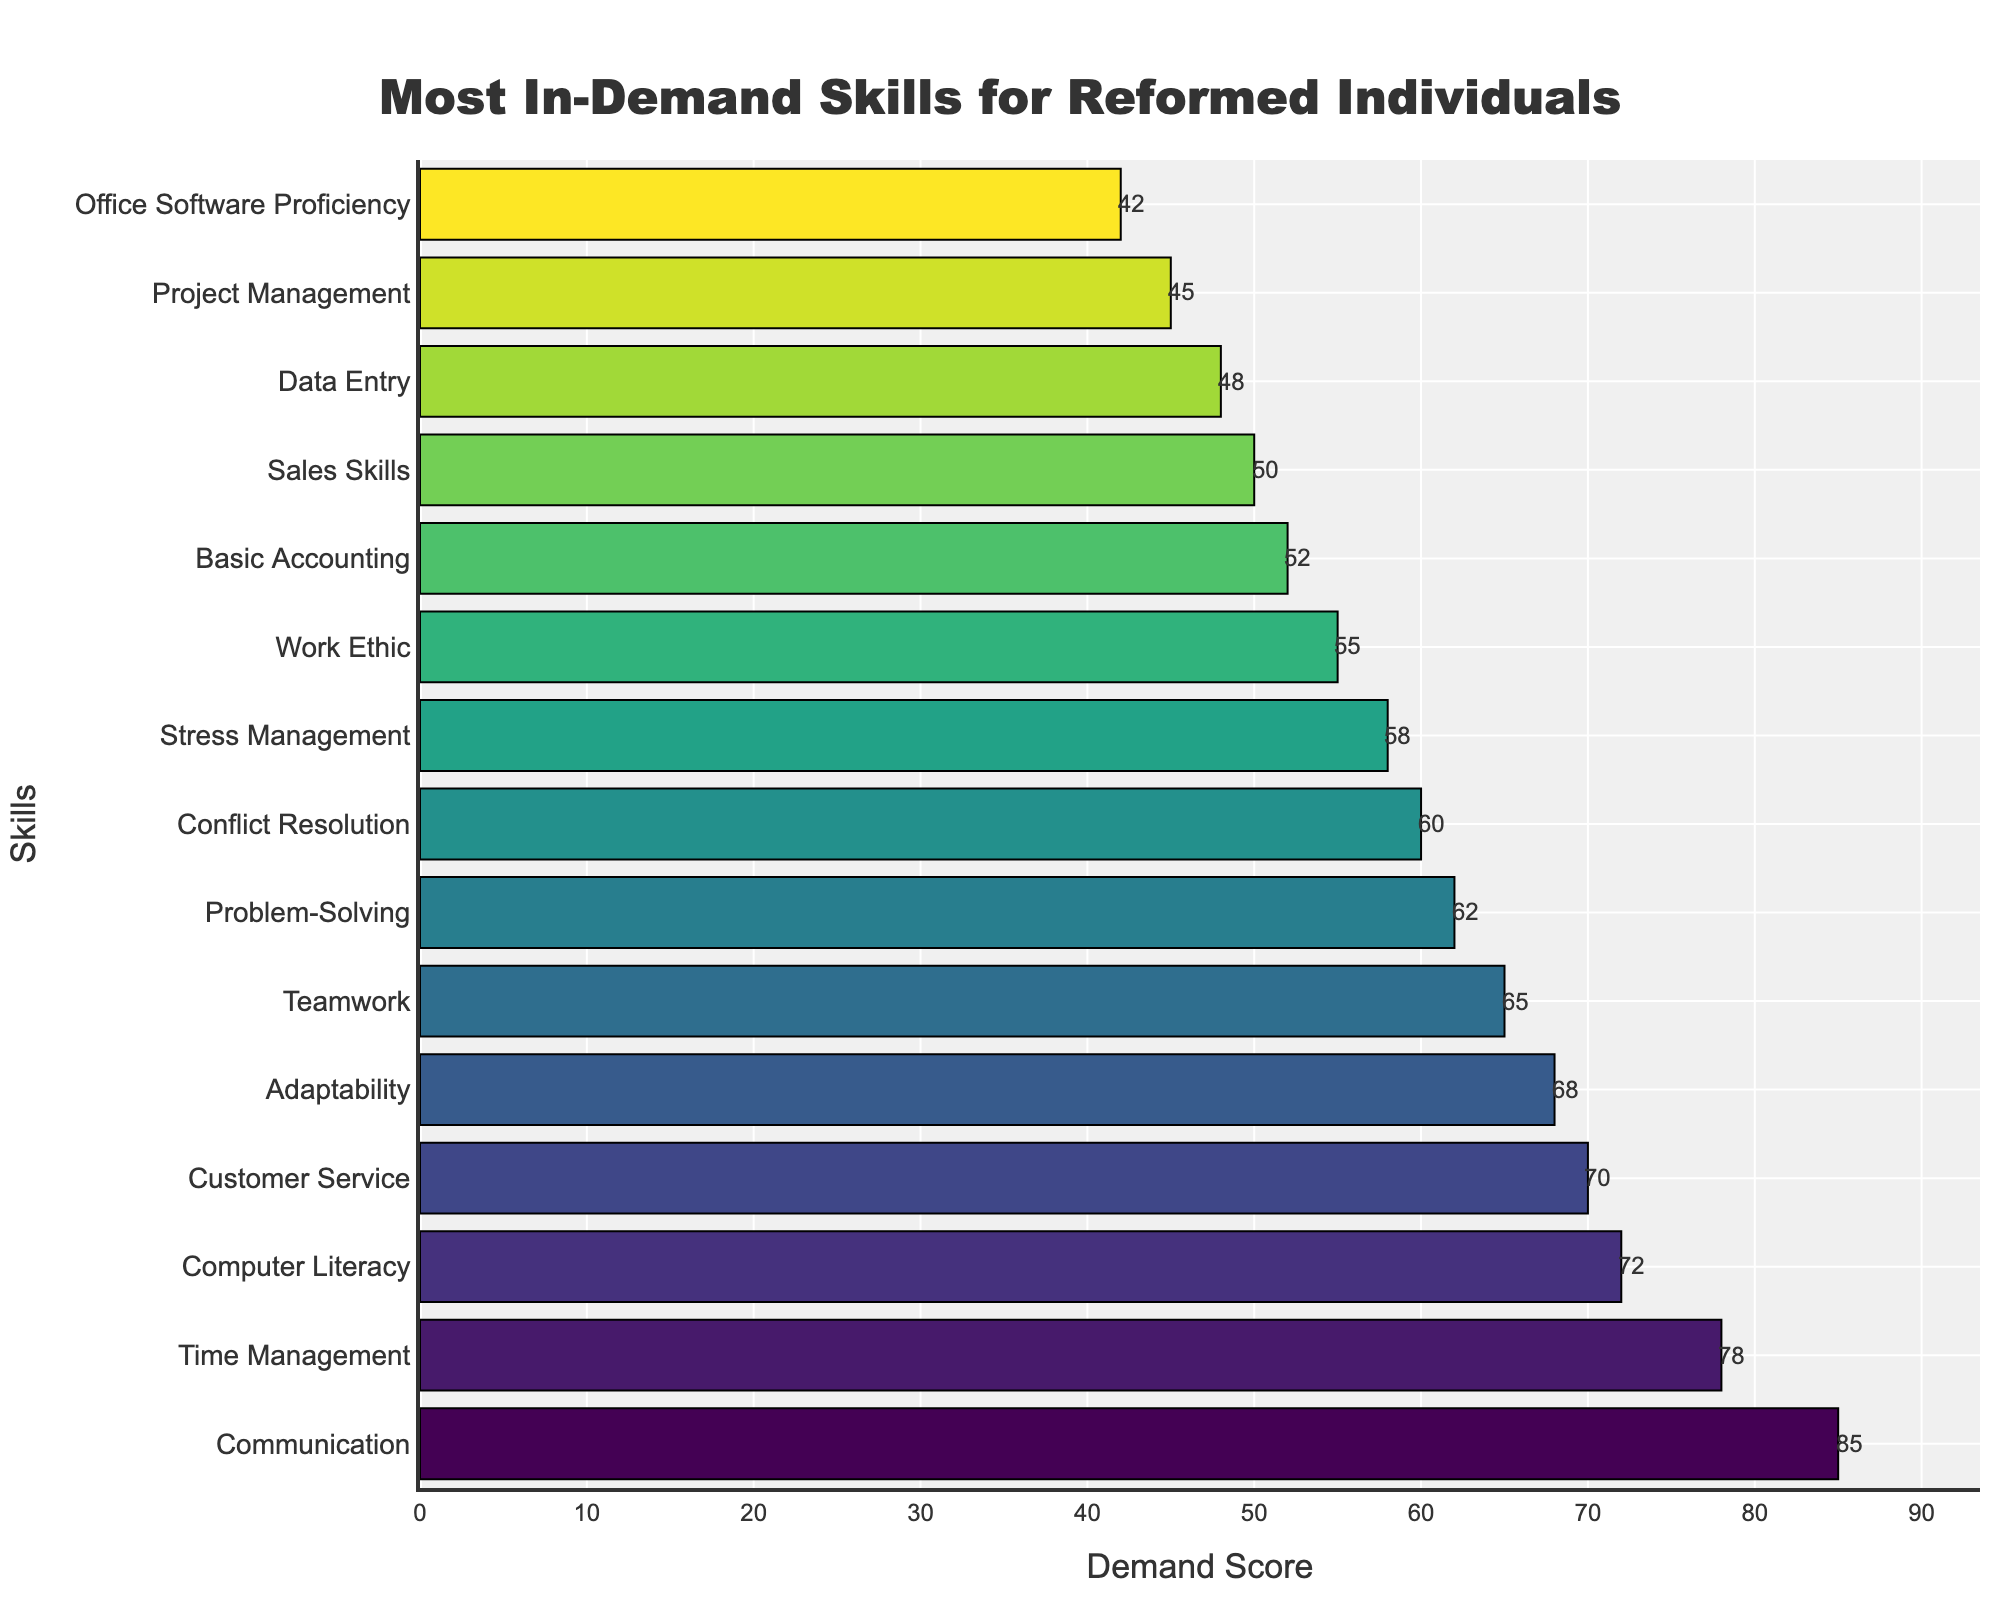What is the highest demand skill according to the figure? The longest bar at the top of the figure represents the highest demand skill. According to the bar chart, the top skill is Communication with a Demand Score of 85.
Answer: Communication Which skill has a higher demand score, Adaptability or Teamwork? Identify the bars representing Adaptability and Teamwork. Adaptability has a Demand Score of 68, and Teamwork has a Demand Score of 65. Since 68 is greater than 65, Adaptability has a higher demand score.
Answer: Adaptability What is the sum of the demand scores for Computer Literacy and Sales Skills? Find the respective bars and their scores. Computer Literacy has a Demand Score of 72, and Sales Skills have a Demand Score of 50. Adding these together yields 72 + 50.
Answer: 122 Which skill has the third highest demand score? Order the bars from highest to lowest demand score. The third bar from the top represents the third highest demand score. According to the figure, the third highest demand skill is Computer Literacy with a Demand Score of 72.
Answer: Computer Literacy How many skills have a demand score greater than 60? Count the number of bars that extend beyond the 60 mark on the x-axis. According to the chart, there are 7 skills (Communication, Time Management, Computer Literacy, Customer Service, Adaptability, Teamwork, Problem-Solving) that have a demand score greater than 60.
Answer: 7 Which skill has the lowest demand score, and what is that score? Look for the shortest bar at the bottom of the chart. The shortest bar represents Office Software Proficiency, which has a Demand Score of 42.
Answer: Office Software Proficiency, 42 What is the average demand score of the top 5 skills? List the Demand Scores of the top 5 skills: Communication (85), Time Management (78), Computer Literacy (72), Customer Service (70), and Adaptability (68). Calculate the average: (85 + 78 + 72 + 70 + 68) / 5 = 74.6.
Answer: 74.6 By how much does the demand score for Conflict Resolution exceed that of Work Ethic? Determine the Demand Scores for Conflict Resolution (60) and Work Ethic (55). Subtract the Demand Score of Work Ethic from that of Conflict Resolution: 60 - 55.
Answer: 5 Which skills have a demand score between 50 and 60? Identify the bars with scores falling in the range of 50 to 60. According to the chart, these skills are Conflict Resolution (60), Stress Management (58), Work Ethic (55), and Basic Accounting (52).
Answer: Conflict Resolution, Stress Management, Work Ethic, Basic Accounting 